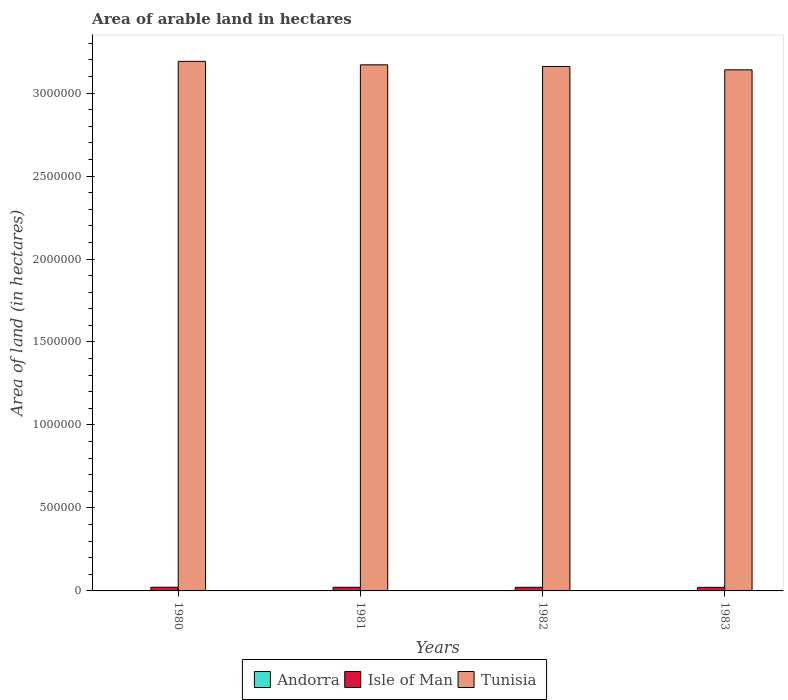How many groups of bars are there?
Your answer should be very brief. 4. Are the number of bars on each tick of the X-axis equal?
Provide a short and direct response. Yes. How many bars are there on the 1st tick from the right?
Offer a very short reply. 3. What is the label of the 4th group of bars from the left?
Make the answer very short. 1983. In how many cases, is the number of bars for a given year not equal to the number of legend labels?
Your answer should be compact. 0. What is the total arable land in Isle of Man in 1981?
Provide a succinct answer. 2.20e+04. Across all years, what is the maximum total arable land in Andorra?
Your answer should be compact. 1000. Across all years, what is the minimum total arable land in Isle of Man?
Your answer should be compact. 2.15e+04. What is the total total arable land in Tunisia in the graph?
Your answer should be compact. 1.27e+07. What is the difference between the total arable land in Isle of Man in 1982 and that in 1983?
Your answer should be very brief. 300. What is the difference between the total arable land in Isle of Man in 1982 and the total arable land in Tunisia in 1980?
Provide a short and direct response. -3.17e+06. In the year 1982, what is the difference between the total arable land in Isle of Man and total arable land in Tunisia?
Keep it short and to the point. -3.14e+06. What is the ratio of the total arable land in Andorra in 1980 to that in 1981?
Provide a short and direct response. 1. Is the total arable land in Tunisia in 1981 less than that in 1983?
Offer a very short reply. No. What is the difference between the highest and the lowest total arable land in Andorra?
Keep it short and to the point. 0. What does the 2nd bar from the left in 1981 represents?
Offer a very short reply. Isle of Man. What does the 3rd bar from the right in 1982 represents?
Offer a terse response. Andorra. How are the legend labels stacked?
Ensure brevity in your answer.  Horizontal. What is the title of the graph?
Ensure brevity in your answer.  Area of arable land in hectares. What is the label or title of the X-axis?
Ensure brevity in your answer.  Years. What is the label or title of the Y-axis?
Make the answer very short. Area of land (in hectares). What is the Area of land (in hectares) in Isle of Man in 1980?
Provide a succinct answer. 2.22e+04. What is the Area of land (in hectares) in Tunisia in 1980?
Keep it short and to the point. 3.19e+06. What is the Area of land (in hectares) in Andorra in 1981?
Your answer should be very brief. 1000. What is the Area of land (in hectares) of Isle of Man in 1981?
Keep it short and to the point. 2.20e+04. What is the Area of land (in hectares) in Tunisia in 1981?
Offer a very short reply. 3.17e+06. What is the Area of land (in hectares) in Isle of Man in 1982?
Make the answer very short. 2.18e+04. What is the Area of land (in hectares) in Tunisia in 1982?
Provide a succinct answer. 3.16e+06. What is the Area of land (in hectares) of Andorra in 1983?
Your response must be concise. 1000. What is the Area of land (in hectares) in Isle of Man in 1983?
Give a very brief answer. 2.15e+04. What is the Area of land (in hectares) of Tunisia in 1983?
Provide a short and direct response. 3.14e+06. Across all years, what is the maximum Area of land (in hectares) in Andorra?
Keep it short and to the point. 1000. Across all years, what is the maximum Area of land (in hectares) in Isle of Man?
Your response must be concise. 2.22e+04. Across all years, what is the maximum Area of land (in hectares) in Tunisia?
Make the answer very short. 3.19e+06. Across all years, what is the minimum Area of land (in hectares) of Andorra?
Provide a succinct answer. 1000. Across all years, what is the minimum Area of land (in hectares) in Isle of Man?
Ensure brevity in your answer.  2.15e+04. Across all years, what is the minimum Area of land (in hectares) in Tunisia?
Your answer should be compact. 3.14e+06. What is the total Area of land (in hectares) in Andorra in the graph?
Your answer should be compact. 4000. What is the total Area of land (in hectares) in Isle of Man in the graph?
Ensure brevity in your answer.  8.75e+04. What is the total Area of land (in hectares) in Tunisia in the graph?
Ensure brevity in your answer.  1.27e+07. What is the difference between the Area of land (in hectares) of Andorra in 1980 and that in 1981?
Your response must be concise. 0. What is the difference between the Area of land (in hectares) of Isle of Man in 1980 and that in 1981?
Provide a succinct answer. 200. What is the difference between the Area of land (in hectares) in Tunisia in 1980 and that in 1981?
Keep it short and to the point. 2.10e+04. What is the difference between the Area of land (in hectares) of Andorra in 1980 and that in 1982?
Your response must be concise. 0. What is the difference between the Area of land (in hectares) of Tunisia in 1980 and that in 1982?
Provide a short and direct response. 3.10e+04. What is the difference between the Area of land (in hectares) in Andorra in 1980 and that in 1983?
Offer a terse response. 0. What is the difference between the Area of land (in hectares) in Isle of Man in 1980 and that in 1983?
Your response must be concise. 700. What is the difference between the Area of land (in hectares) of Tunisia in 1980 and that in 1983?
Provide a short and direct response. 5.10e+04. What is the difference between the Area of land (in hectares) in Isle of Man in 1981 and that in 1982?
Provide a succinct answer. 200. What is the difference between the Area of land (in hectares) in Tunisia in 1981 and that in 1982?
Keep it short and to the point. 10000. What is the difference between the Area of land (in hectares) in Tunisia in 1981 and that in 1983?
Give a very brief answer. 3.00e+04. What is the difference between the Area of land (in hectares) of Andorra in 1982 and that in 1983?
Provide a short and direct response. 0. What is the difference between the Area of land (in hectares) of Isle of Man in 1982 and that in 1983?
Offer a very short reply. 300. What is the difference between the Area of land (in hectares) of Andorra in 1980 and the Area of land (in hectares) of Isle of Man in 1981?
Your response must be concise. -2.10e+04. What is the difference between the Area of land (in hectares) of Andorra in 1980 and the Area of land (in hectares) of Tunisia in 1981?
Ensure brevity in your answer.  -3.17e+06. What is the difference between the Area of land (in hectares) of Isle of Man in 1980 and the Area of land (in hectares) of Tunisia in 1981?
Your response must be concise. -3.15e+06. What is the difference between the Area of land (in hectares) in Andorra in 1980 and the Area of land (in hectares) in Isle of Man in 1982?
Keep it short and to the point. -2.08e+04. What is the difference between the Area of land (in hectares) of Andorra in 1980 and the Area of land (in hectares) of Tunisia in 1982?
Make the answer very short. -3.16e+06. What is the difference between the Area of land (in hectares) in Isle of Man in 1980 and the Area of land (in hectares) in Tunisia in 1982?
Make the answer very short. -3.14e+06. What is the difference between the Area of land (in hectares) of Andorra in 1980 and the Area of land (in hectares) of Isle of Man in 1983?
Provide a short and direct response. -2.05e+04. What is the difference between the Area of land (in hectares) of Andorra in 1980 and the Area of land (in hectares) of Tunisia in 1983?
Offer a very short reply. -3.14e+06. What is the difference between the Area of land (in hectares) of Isle of Man in 1980 and the Area of land (in hectares) of Tunisia in 1983?
Offer a very short reply. -3.12e+06. What is the difference between the Area of land (in hectares) of Andorra in 1981 and the Area of land (in hectares) of Isle of Man in 1982?
Offer a terse response. -2.08e+04. What is the difference between the Area of land (in hectares) of Andorra in 1981 and the Area of land (in hectares) of Tunisia in 1982?
Keep it short and to the point. -3.16e+06. What is the difference between the Area of land (in hectares) of Isle of Man in 1981 and the Area of land (in hectares) of Tunisia in 1982?
Give a very brief answer. -3.14e+06. What is the difference between the Area of land (in hectares) of Andorra in 1981 and the Area of land (in hectares) of Isle of Man in 1983?
Offer a terse response. -2.05e+04. What is the difference between the Area of land (in hectares) in Andorra in 1981 and the Area of land (in hectares) in Tunisia in 1983?
Provide a short and direct response. -3.14e+06. What is the difference between the Area of land (in hectares) of Isle of Man in 1981 and the Area of land (in hectares) of Tunisia in 1983?
Provide a short and direct response. -3.12e+06. What is the difference between the Area of land (in hectares) in Andorra in 1982 and the Area of land (in hectares) in Isle of Man in 1983?
Your answer should be very brief. -2.05e+04. What is the difference between the Area of land (in hectares) of Andorra in 1982 and the Area of land (in hectares) of Tunisia in 1983?
Give a very brief answer. -3.14e+06. What is the difference between the Area of land (in hectares) in Isle of Man in 1982 and the Area of land (in hectares) in Tunisia in 1983?
Your answer should be very brief. -3.12e+06. What is the average Area of land (in hectares) in Isle of Man per year?
Offer a terse response. 2.19e+04. What is the average Area of land (in hectares) of Tunisia per year?
Make the answer very short. 3.17e+06. In the year 1980, what is the difference between the Area of land (in hectares) in Andorra and Area of land (in hectares) in Isle of Man?
Provide a succinct answer. -2.12e+04. In the year 1980, what is the difference between the Area of land (in hectares) of Andorra and Area of land (in hectares) of Tunisia?
Provide a succinct answer. -3.19e+06. In the year 1980, what is the difference between the Area of land (in hectares) in Isle of Man and Area of land (in hectares) in Tunisia?
Make the answer very short. -3.17e+06. In the year 1981, what is the difference between the Area of land (in hectares) in Andorra and Area of land (in hectares) in Isle of Man?
Provide a short and direct response. -2.10e+04. In the year 1981, what is the difference between the Area of land (in hectares) of Andorra and Area of land (in hectares) of Tunisia?
Keep it short and to the point. -3.17e+06. In the year 1981, what is the difference between the Area of land (in hectares) of Isle of Man and Area of land (in hectares) of Tunisia?
Your response must be concise. -3.15e+06. In the year 1982, what is the difference between the Area of land (in hectares) of Andorra and Area of land (in hectares) of Isle of Man?
Your response must be concise. -2.08e+04. In the year 1982, what is the difference between the Area of land (in hectares) of Andorra and Area of land (in hectares) of Tunisia?
Your response must be concise. -3.16e+06. In the year 1982, what is the difference between the Area of land (in hectares) in Isle of Man and Area of land (in hectares) in Tunisia?
Ensure brevity in your answer.  -3.14e+06. In the year 1983, what is the difference between the Area of land (in hectares) of Andorra and Area of land (in hectares) of Isle of Man?
Your answer should be very brief. -2.05e+04. In the year 1983, what is the difference between the Area of land (in hectares) of Andorra and Area of land (in hectares) of Tunisia?
Provide a succinct answer. -3.14e+06. In the year 1983, what is the difference between the Area of land (in hectares) of Isle of Man and Area of land (in hectares) of Tunisia?
Keep it short and to the point. -3.12e+06. What is the ratio of the Area of land (in hectares) of Andorra in 1980 to that in 1981?
Offer a terse response. 1. What is the ratio of the Area of land (in hectares) in Isle of Man in 1980 to that in 1981?
Provide a succinct answer. 1.01. What is the ratio of the Area of land (in hectares) of Tunisia in 1980 to that in 1981?
Make the answer very short. 1.01. What is the ratio of the Area of land (in hectares) in Isle of Man in 1980 to that in 1982?
Your response must be concise. 1.02. What is the ratio of the Area of land (in hectares) in Tunisia in 1980 to that in 1982?
Give a very brief answer. 1.01. What is the ratio of the Area of land (in hectares) of Andorra in 1980 to that in 1983?
Your answer should be compact. 1. What is the ratio of the Area of land (in hectares) in Isle of Man in 1980 to that in 1983?
Keep it short and to the point. 1.03. What is the ratio of the Area of land (in hectares) of Tunisia in 1980 to that in 1983?
Your response must be concise. 1.02. What is the ratio of the Area of land (in hectares) in Isle of Man in 1981 to that in 1982?
Offer a very short reply. 1.01. What is the ratio of the Area of land (in hectares) in Andorra in 1981 to that in 1983?
Keep it short and to the point. 1. What is the ratio of the Area of land (in hectares) of Isle of Man in 1981 to that in 1983?
Ensure brevity in your answer.  1.02. What is the ratio of the Area of land (in hectares) of Tunisia in 1981 to that in 1983?
Make the answer very short. 1.01. What is the ratio of the Area of land (in hectares) in Andorra in 1982 to that in 1983?
Your response must be concise. 1. What is the ratio of the Area of land (in hectares) of Tunisia in 1982 to that in 1983?
Keep it short and to the point. 1.01. What is the difference between the highest and the second highest Area of land (in hectares) in Andorra?
Your answer should be compact. 0. What is the difference between the highest and the second highest Area of land (in hectares) in Isle of Man?
Your answer should be very brief. 200. What is the difference between the highest and the second highest Area of land (in hectares) in Tunisia?
Offer a very short reply. 2.10e+04. What is the difference between the highest and the lowest Area of land (in hectares) of Isle of Man?
Your answer should be very brief. 700. What is the difference between the highest and the lowest Area of land (in hectares) of Tunisia?
Provide a short and direct response. 5.10e+04. 